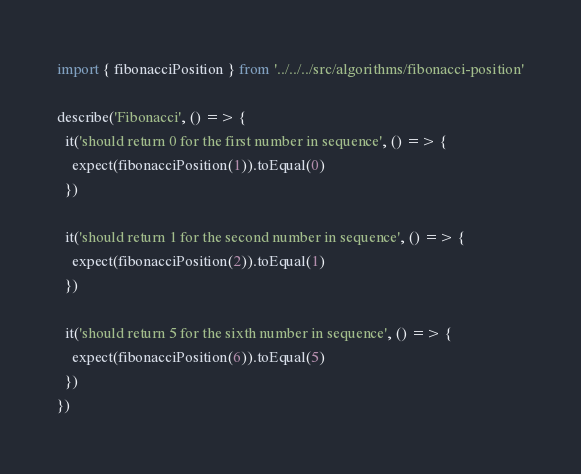<code> <loc_0><loc_0><loc_500><loc_500><_JavaScript_>import { fibonacciPosition } from '../../../src/algorithms/fibonacci-position'

describe('Fibonacci', () => {
  it('should return 0 for the first number in sequence', () => {
    expect(fibonacciPosition(1)).toEqual(0)
  })

  it('should return 1 for the second number in sequence', () => {
    expect(fibonacciPosition(2)).toEqual(1)
  })

  it('should return 5 for the sixth number in sequence', () => {
    expect(fibonacciPosition(6)).toEqual(5)
  })
})
</code> 